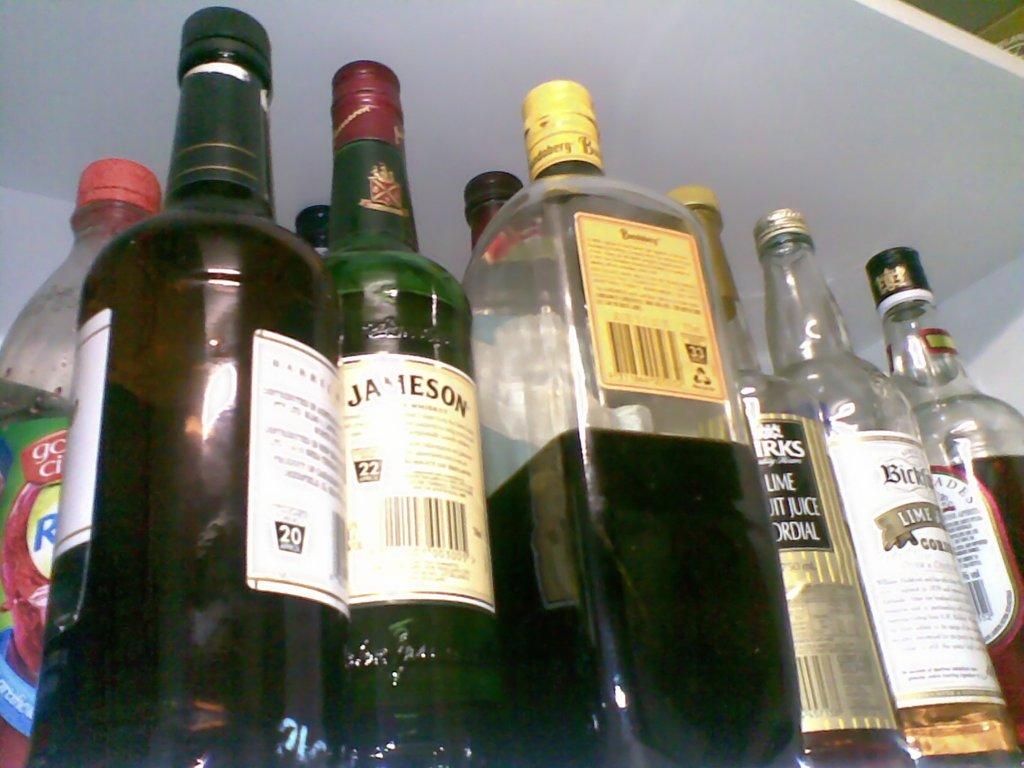What brand is the alcohol in the green bottle?
Your answer should be compact. Jameson. 